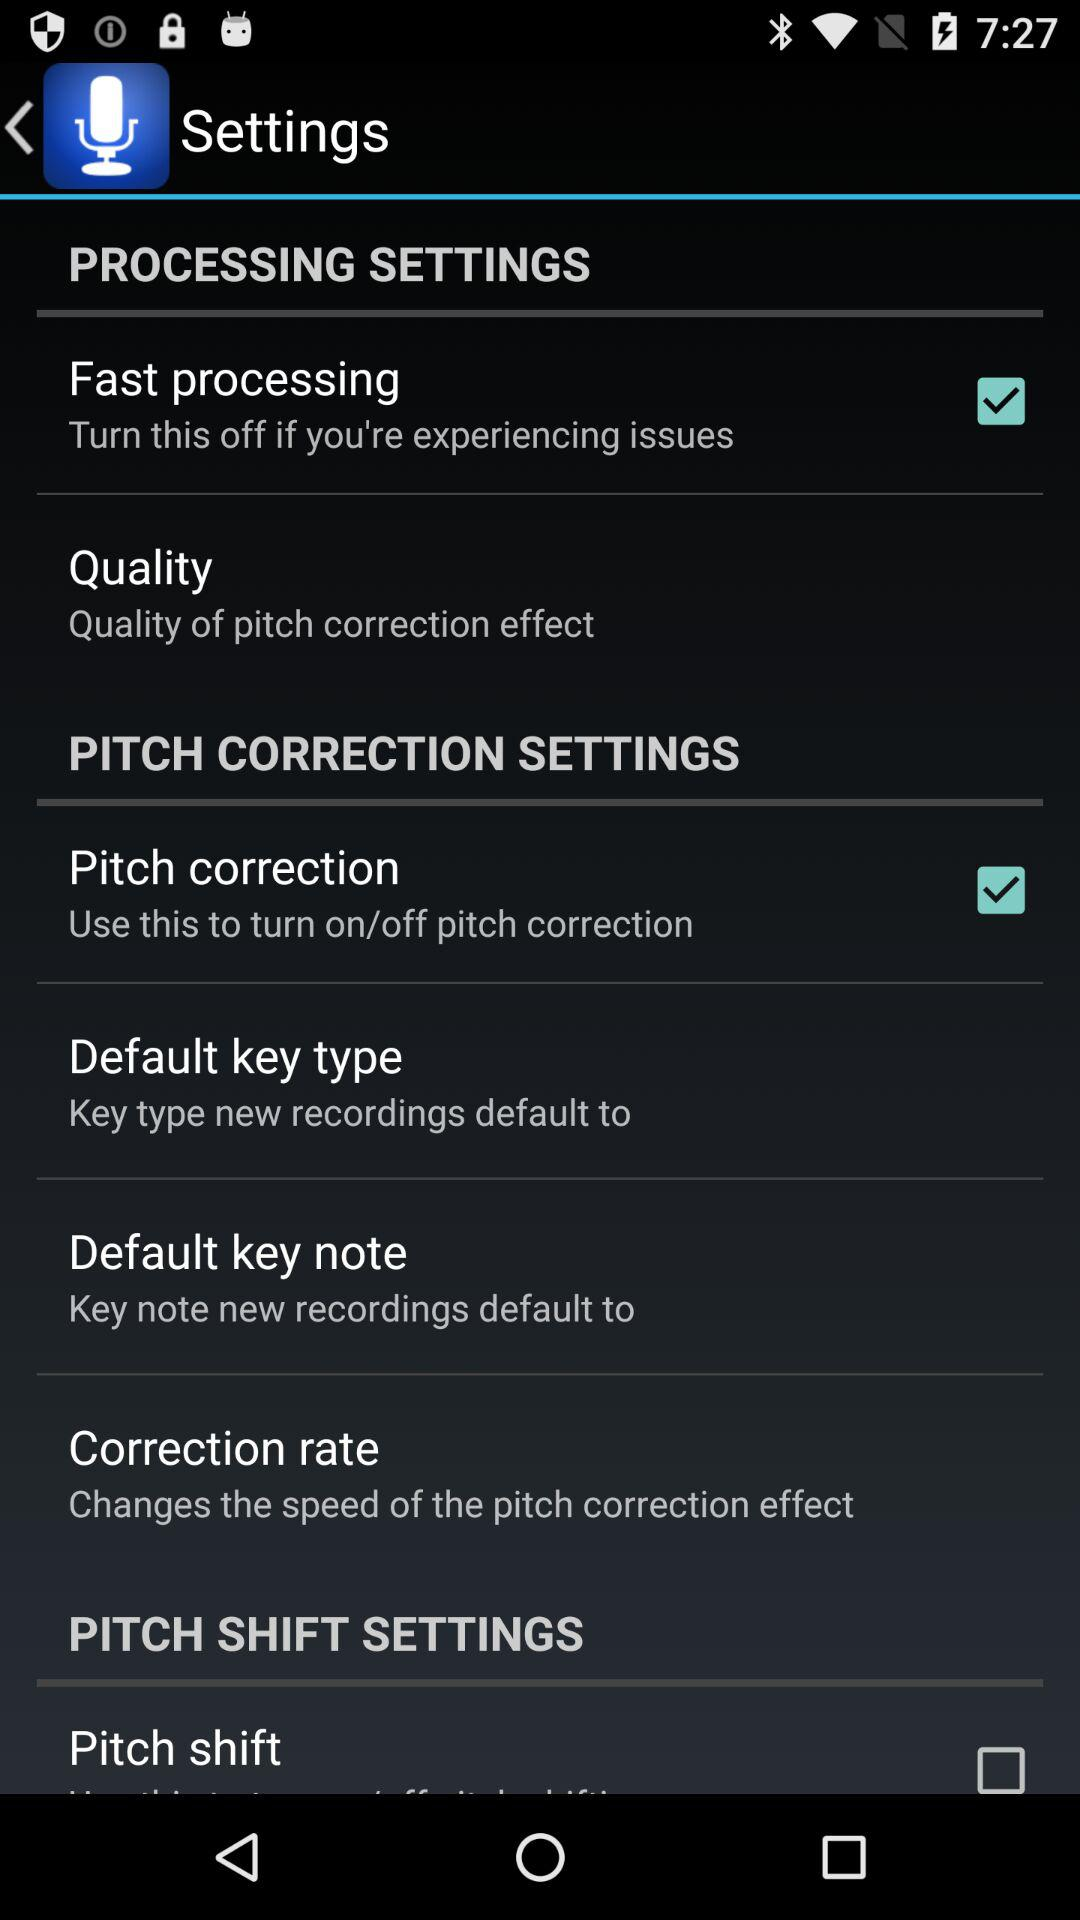Is "Pitch shift" checked or unchecked? "Pitch shift" is unchecked. 